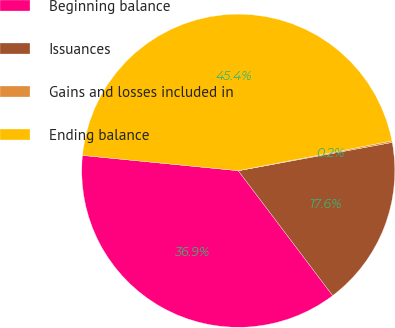Convert chart to OTSL. <chart><loc_0><loc_0><loc_500><loc_500><pie_chart><fcel>Beginning balance<fcel>Issuances<fcel>Gains and losses included in<fcel>Ending balance<nl><fcel>36.86%<fcel>17.59%<fcel>0.16%<fcel>45.39%<nl></chart> 